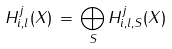<formula> <loc_0><loc_0><loc_500><loc_500>H ^ { j } _ { i , l } ( X ) \, = \, \bigoplus _ { S } { H ^ { j } _ { i , l , S } ( X ) }</formula> 